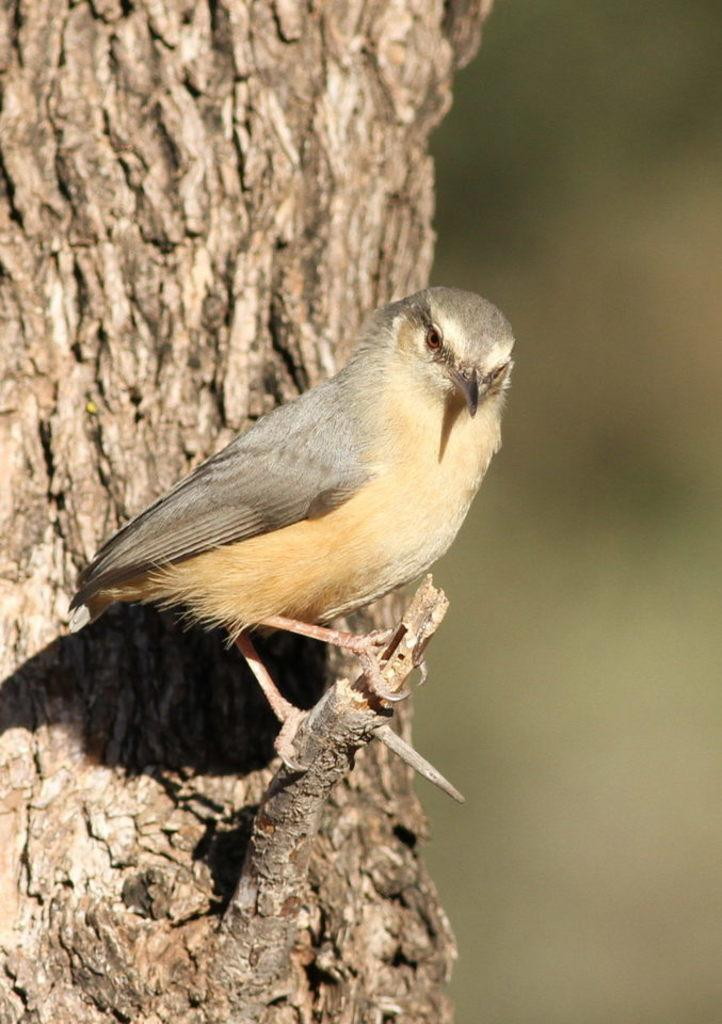What type of animal can be seen in the image? There is a bird in the image. Where is the bird located in the image? The bird is on a tree branch. Can you describe the position of the tree branch in the image? The tree branch is in the center of the image. What type of ghost can be seen interacting with the bird in the image? There is no ghost present in the image; it features a bird on a tree branch. What team is responsible for maintaining the cemetery in the image? There is no cemetery present in the image; it features a bird on a tree branch. 